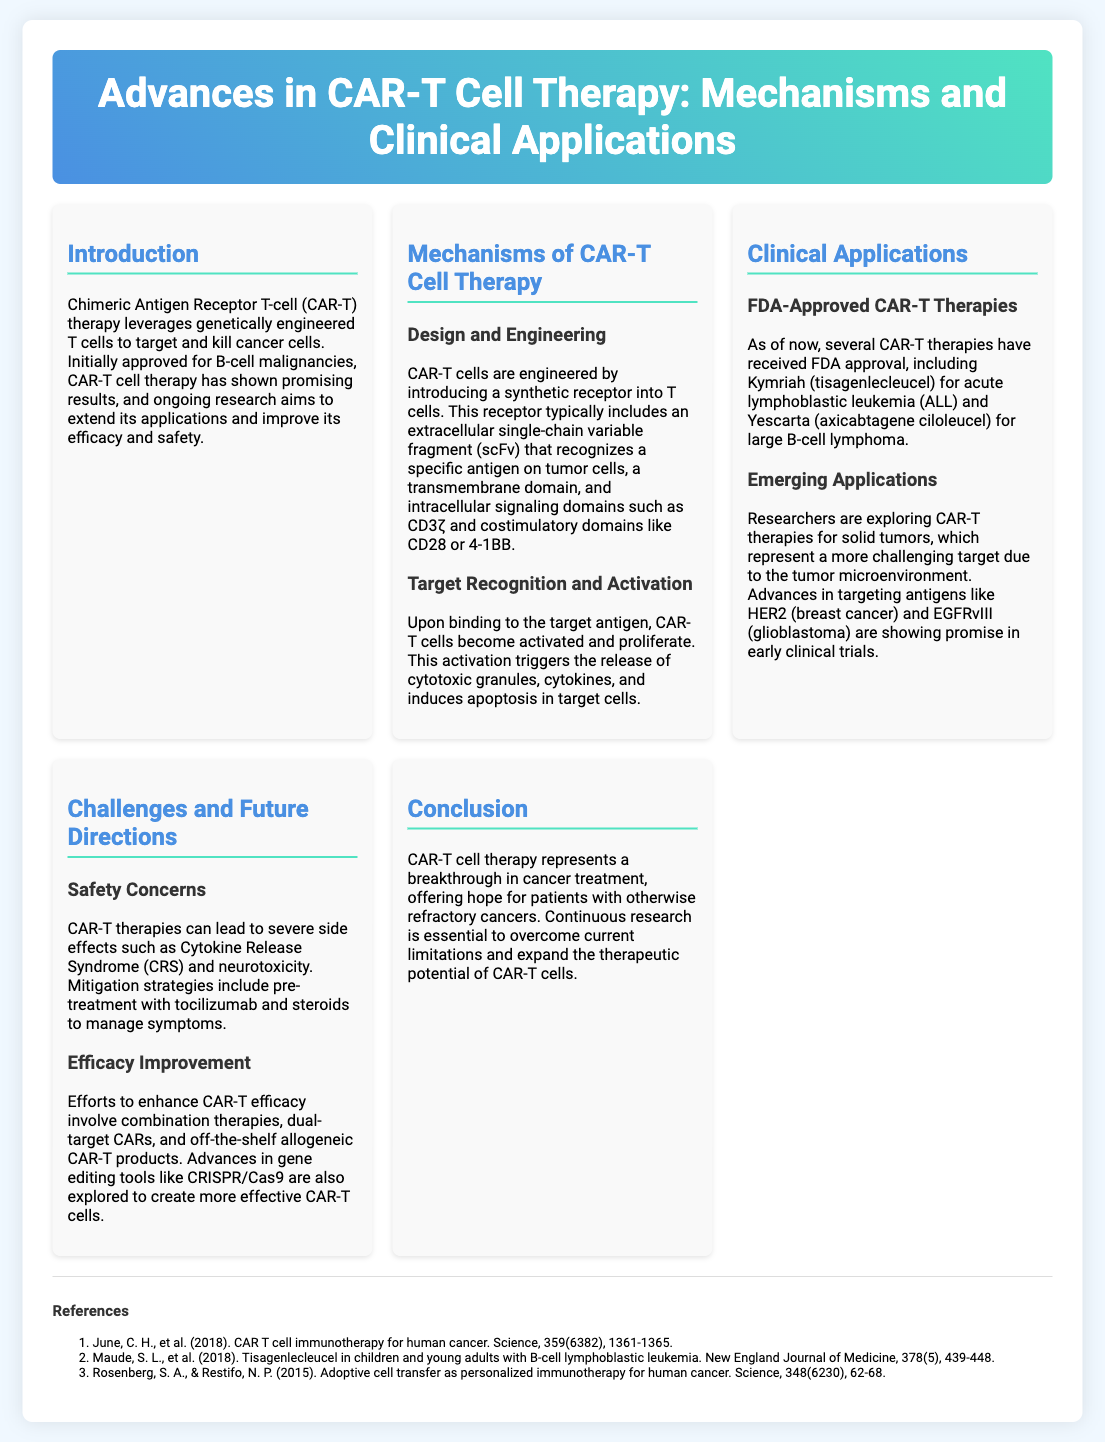What is CAR-T therapy? CAR-T therapy, or Chimeric Antigen Receptor T-cell therapy, utilizes genetically engineered T cells to target and kill cancer cells.
Answer: CAR-T therapy What are the FDA-approved CAR-T therapies mentioned? The document lists Kymriah for acute lymphoblastic leukemia and Yescarta for large B-cell lymphoma as FDA-approved CAR-T therapies.
Answer: Kymriah and Yescarta What is the primary function of the scFv in CAR-T cells? The scFv recognizes a specific antigen on tumor cells, initiating the therapeutic response.
Answer: Recognizes a specific antigen What severe side effects are associated with CAR-T therapies? The document mentions Cytokine Release Syndrome and neurotoxicity as severe side effects.
Answer: Cytokine Release Syndrome and neurotoxicity What is one strategy to mitigate CAR-T side effects? Pre-treatment with tocilizumab and steroids is suggested to manage symptoms of CAR-T side effects.
Answer: Tocilizumab and steroids Which gene editing tool is explored to enhance CAR-T efficacy? The poster refers to CRISPR/Cas9 as a gene editing tool being explored for creating more effective CAR-T cells.
Answer: CRISPR/Cas9 What emerging application of CAR-T therapy is being explored? Researchers are exploring CAR-T therapies for solid tumors, which pose more challenges than blood cancers.
Answer: Solid tumors What is a recent challenge in applying CAR-T therapy? The tumor microenvironment presents a more challenging target for CAR-T therapy applications.
Answer: Tumor microenvironment 